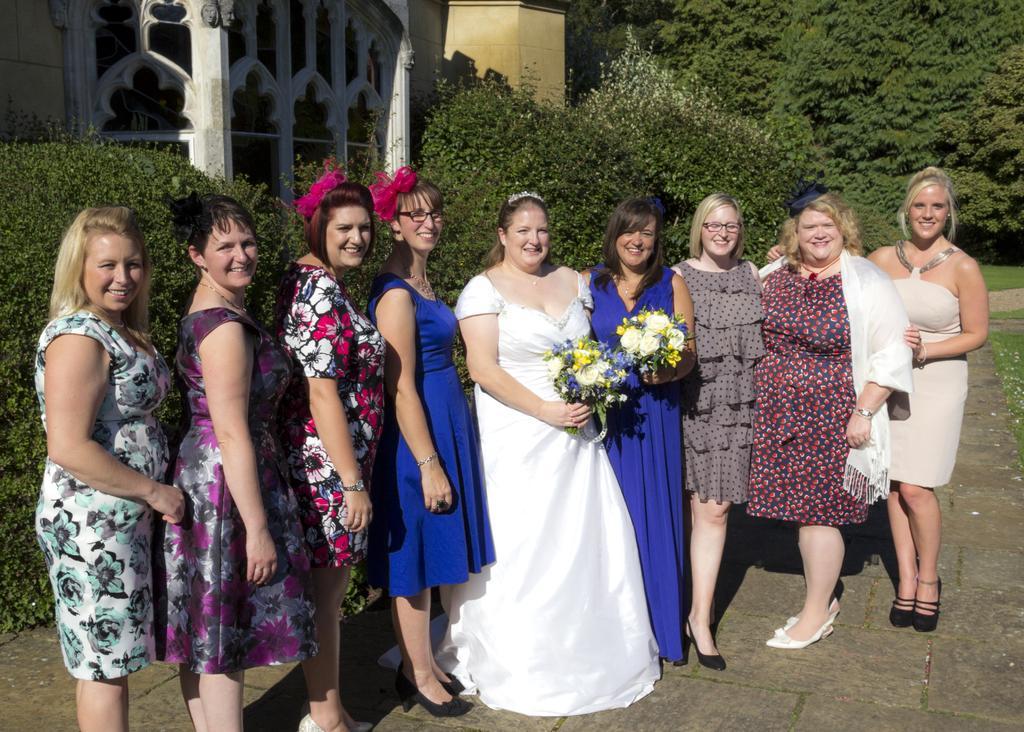Please provide a concise description of this image. This image is taken outdoors. At the bottom of the image there is a floor. In the background there are many trees and plants and there is a church with a few walls, doors and pillars. In the middle of the image a few women are standing on the floor and a woman who has worn a white frock is holding a bouquet in her hand. 